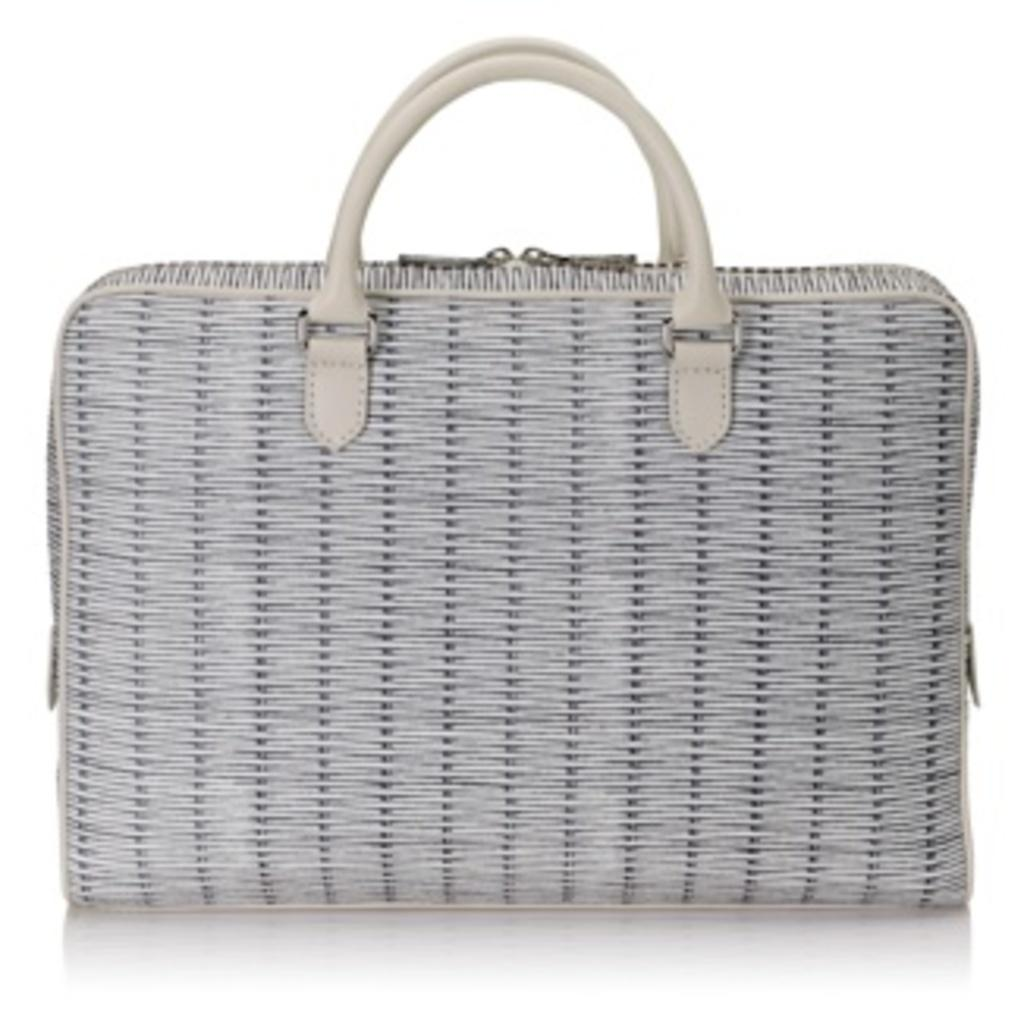What is the main subject of the image? The main subject of the image is a bag. What color is the bag? The bag is grey in color. How many handles does the bag have, and what color are they? The bag has two cream-colored handles. What color is the background of the image? The background of the image is white. How many bells are attached to the bag in the image? There are no bells attached to the bag in the image. 